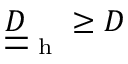Convert formula to latex. <formula><loc_0><loc_0><loc_500><loc_500>\underline { { \underline { D } } } _ { h } \geq D</formula> 